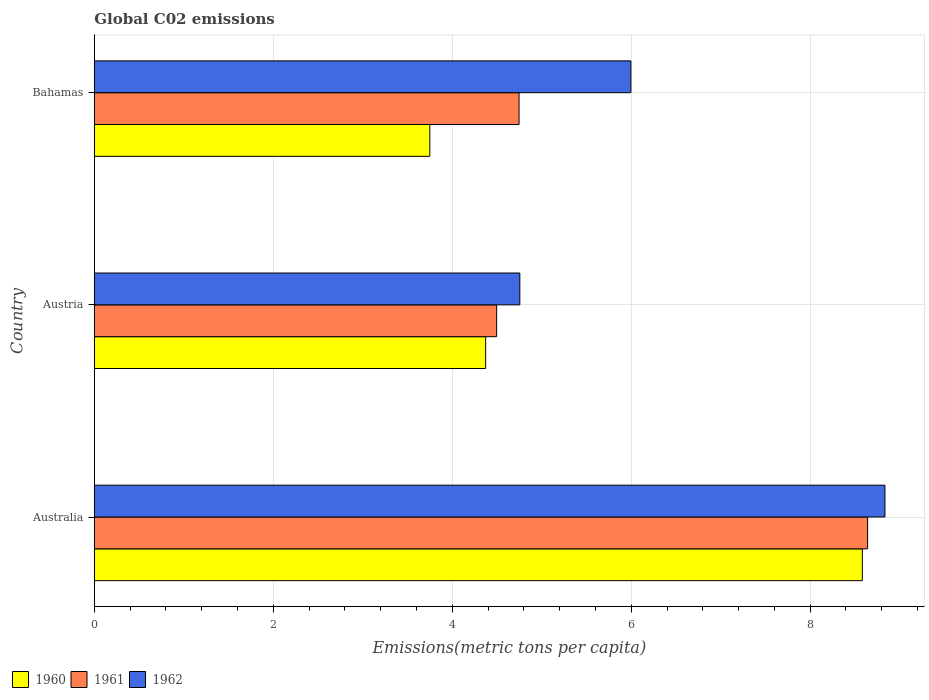How many different coloured bars are there?
Provide a short and direct response. 3. Are the number of bars per tick equal to the number of legend labels?
Make the answer very short. Yes. Are the number of bars on each tick of the Y-axis equal?
Make the answer very short. Yes. What is the label of the 2nd group of bars from the top?
Offer a very short reply. Austria. In how many cases, is the number of bars for a given country not equal to the number of legend labels?
Offer a terse response. 0. What is the amount of CO2 emitted in in 1960 in Bahamas?
Keep it short and to the point. 3.75. Across all countries, what is the maximum amount of CO2 emitted in in 1960?
Your answer should be very brief. 8.58. Across all countries, what is the minimum amount of CO2 emitted in in 1962?
Your response must be concise. 4.76. In which country was the amount of CO2 emitted in in 1960 minimum?
Your response must be concise. Bahamas. What is the total amount of CO2 emitted in in 1961 in the graph?
Your answer should be compact. 17.88. What is the difference between the amount of CO2 emitted in in 1962 in Australia and that in Bahamas?
Provide a short and direct response. 2.84. What is the difference between the amount of CO2 emitted in in 1962 in Bahamas and the amount of CO2 emitted in in 1961 in Australia?
Your response must be concise. -2.65. What is the average amount of CO2 emitted in in 1961 per country?
Your answer should be compact. 5.96. What is the difference between the amount of CO2 emitted in in 1960 and amount of CO2 emitted in in 1962 in Australia?
Give a very brief answer. -0.25. In how many countries, is the amount of CO2 emitted in in 1960 greater than 7.2 metric tons per capita?
Offer a terse response. 1. What is the ratio of the amount of CO2 emitted in in 1962 in Austria to that in Bahamas?
Your response must be concise. 0.79. Is the amount of CO2 emitted in in 1962 in Austria less than that in Bahamas?
Your answer should be very brief. Yes. What is the difference between the highest and the second highest amount of CO2 emitted in in 1961?
Offer a very short reply. 3.89. What is the difference between the highest and the lowest amount of CO2 emitted in in 1960?
Provide a short and direct response. 4.83. What does the 3rd bar from the top in Australia represents?
Your answer should be very brief. 1960. What does the 3rd bar from the bottom in Australia represents?
Provide a short and direct response. 1962. What is the difference between two consecutive major ticks on the X-axis?
Ensure brevity in your answer.  2. Are the values on the major ticks of X-axis written in scientific E-notation?
Your response must be concise. No. Does the graph contain any zero values?
Keep it short and to the point. No. Does the graph contain grids?
Make the answer very short. Yes. What is the title of the graph?
Keep it short and to the point. Global C02 emissions. Does "1999" appear as one of the legend labels in the graph?
Give a very brief answer. No. What is the label or title of the X-axis?
Offer a terse response. Emissions(metric tons per capita). What is the label or title of the Y-axis?
Offer a very short reply. Country. What is the Emissions(metric tons per capita) of 1960 in Australia?
Give a very brief answer. 8.58. What is the Emissions(metric tons per capita) in 1961 in Australia?
Offer a terse response. 8.64. What is the Emissions(metric tons per capita) of 1962 in Australia?
Your answer should be very brief. 8.84. What is the Emissions(metric tons per capita) of 1960 in Austria?
Your response must be concise. 4.37. What is the Emissions(metric tons per capita) in 1961 in Austria?
Offer a terse response. 4.5. What is the Emissions(metric tons per capita) in 1962 in Austria?
Provide a short and direct response. 4.76. What is the Emissions(metric tons per capita) of 1960 in Bahamas?
Ensure brevity in your answer.  3.75. What is the Emissions(metric tons per capita) in 1961 in Bahamas?
Your answer should be compact. 4.75. What is the Emissions(metric tons per capita) of 1962 in Bahamas?
Offer a very short reply. 6. Across all countries, what is the maximum Emissions(metric tons per capita) of 1960?
Ensure brevity in your answer.  8.58. Across all countries, what is the maximum Emissions(metric tons per capita) in 1961?
Offer a very short reply. 8.64. Across all countries, what is the maximum Emissions(metric tons per capita) of 1962?
Make the answer very short. 8.84. Across all countries, what is the minimum Emissions(metric tons per capita) in 1960?
Provide a short and direct response. 3.75. Across all countries, what is the minimum Emissions(metric tons per capita) in 1961?
Ensure brevity in your answer.  4.5. Across all countries, what is the minimum Emissions(metric tons per capita) in 1962?
Your answer should be compact. 4.76. What is the total Emissions(metric tons per capita) in 1960 in the graph?
Your answer should be compact. 16.71. What is the total Emissions(metric tons per capita) in 1961 in the graph?
Offer a terse response. 17.88. What is the total Emissions(metric tons per capita) of 1962 in the graph?
Your response must be concise. 19.59. What is the difference between the Emissions(metric tons per capita) of 1960 in Australia and that in Austria?
Provide a short and direct response. 4.21. What is the difference between the Emissions(metric tons per capita) of 1961 in Australia and that in Austria?
Give a very brief answer. 4.15. What is the difference between the Emissions(metric tons per capita) in 1962 in Australia and that in Austria?
Ensure brevity in your answer.  4.08. What is the difference between the Emissions(metric tons per capita) of 1960 in Australia and that in Bahamas?
Your response must be concise. 4.83. What is the difference between the Emissions(metric tons per capita) of 1961 in Australia and that in Bahamas?
Give a very brief answer. 3.89. What is the difference between the Emissions(metric tons per capita) in 1962 in Australia and that in Bahamas?
Your answer should be compact. 2.84. What is the difference between the Emissions(metric tons per capita) in 1960 in Austria and that in Bahamas?
Provide a succinct answer. 0.62. What is the difference between the Emissions(metric tons per capita) of 1961 in Austria and that in Bahamas?
Ensure brevity in your answer.  -0.25. What is the difference between the Emissions(metric tons per capita) in 1962 in Austria and that in Bahamas?
Offer a very short reply. -1.24. What is the difference between the Emissions(metric tons per capita) of 1960 in Australia and the Emissions(metric tons per capita) of 1961 in Austria?
Your response must be concise. 4.09. What is the difference between the Emissions(metric tons per capita) of 1960 in Australia and the Emissions(metric tons per capita) of 1962 in Austria?
Your answer should be very brief. 3.83. What is the difference between the Emissions(metric tons per capita) of 1961 in Australia and the Emissions(metric tons per capita) of 1962 in Austria?
Your answer should be very brief. 3.89. What is the difference between the Emissions(metric tons per capita) in 1960 in Australia and the Emissions(metric tons per capita) in 1961 in Bahamas?
Provide a succinct answer. 3.84. What is the difference between the Emissions(metric tons per capita) in 1960 in Australia and the Emissions(metric tons per capita) in 1962 in Bahamas?
Ensure brevity in your answer.  2.59. What is the difference between the Emissions(metric tons per capita) of 1961 in Australia and the Emissions(metric tons per capita) of 1962 in Bahamas?
Ensure brevity in your answer.  2.65. What is the difference between the Emissions(metric tons per capita) in 1960 in Austria and the Emissions(metric tons per capita) in 1961 in Bahamas?
Your answer should be compact. -0.37. What is the difference between the Emissions(metric tons per capita) of 1960 in Austria and the Emissions(metric tons per capita) of 1962 in Bahamas?
Offer a terse response. -1.62. What is the difference between the Emissions(metric tons per capita) in 1961 in Austria and the Emissions(metric tons per capita) in 1962 in Bahamas?
Make the answer very short. -1.5. What is the average Emissions(metric tons per capita) in 1960 per country?
Ensure brevity in your answer.  5.57. What is the average Emissions(metric tons per capita) of 1961 per country?
Ensure brevity in your answer.  5.96. What is the average Emissions(metric tons per capita) in 1962 per country?
Ensure brevity in your answer.  6.53. What is the difference between the Emissions(metric tons per capita) of 1960 and Emissions(metric tons per capita) of 1961 in Australia?
Make the answer very short. -0.06. What is the difference between the Emissions(metric tons per capita) of 1960 and Emissions(metric tons per capita) of 1962 in Australia?
Offer a terse response. -0.25. What is the difference between the Emissions(metric tons per capita) of 1961 and Emissions(metric tons per capita) of 1962 in Australia?
Make the answer very short. -0.19. What is the difference between the Emissions(metric tons per capita) in 1960 and Emissions(metric tons per capita) in 1961 in Austria?
Provide a short and direct response. -0.12. What is the difference between the Emissions(metric tons per capita) in 1960 and Emissions(metric tons per capita) in 1962 in Austria?
Make the answer very short. -0.38. What is the difference between the Emissions(metric tons per capita) of 1961 and Emissions(metric tons per capita) of 1962 in Austria?
Provide a succinct answer. -0.26. What is the difference between the Emissions(metric tons per capita) of 1960 and Emissions(metric tons per capita) of 1961 in Bahamas?
Your answer should be compact. -1. What is the difference between the Emissions(metric tons per capita) of 1960 and Emissions(metric tons per capita) of 1962 in Bahamas?
Offer a very short reply. -2.25. What is the difference between the Emissions(metric tons per capita) of 1961 and Emissions(metric tons per capita) of 1962 in Bahamas?
Your response must be concise. -1.25. What is the ratio of the Emissions(metric tons per capita) in 1960 in Australia to that in Austria?
Keep it short and to the point. 1.96. What is the ratio of the Emissions(metric tons per capita) in 1961 in Australia to that in Austria?
Provide a short and direct response. 1.92. What is the ratio of the Emissions(metric tons per capita) in 1962 in Australia to that in Austria?
Ensure brevity in your answer.  1.86. What is the ratio of the Emissions(metric tons per capita) of 1960 in Australia to that in Bahamas?
Give a very brief answer. 2.29. What is the ratio of the Emissions(metric tons per capita) of 1961 in Australia to that in Bahamas?
Offer a very short reply. 1.82. What is the ratio of the Emissions(metric tons per capita) of 1962 in Australia to that in Bahamas?
Your response must be concise. 1.47. What is the ratio of the Emissions(metric tons per capita) in 1960 in Austria to that in Bahamas?
Ensure brevity in your answer.  1.17. What is the ratio of the Emissions(metric tons per capita) of 1961 in Austria to that in Bahamas?
Provide a short and direct response. 0.95. What is the ratio of the Emissions(metric tons per capita) in 1962 in Austria to that in Bahamas?
Provide a short and direct response. 0.79. What is the difference between the highest and the second highest Emissions(metric tons per capita) in 1960?
Keep it short and to the point. 4.21. What is the difference between the highest and the second highest Emissions(metric tons per capita) of 1961?
Offer a terse response. 3.89. What is the difference between the highest and the second highest Emissions(metric tons per capita) of 1962?
Offer a terse response. 2.84. What is the difference between the highest and the lowest Emissions(metric tons per capita) of 1960?
Offer a terse response. 4.83. What is the difference between the highest and the lowest Emissions(metric tons per capita) in 1961?
Your response must be concise. 4.15. What is the difference between the highest and the lowest Emissions(metric tons per capita) in 1962?
Keep it short and to the point. 4.08. 